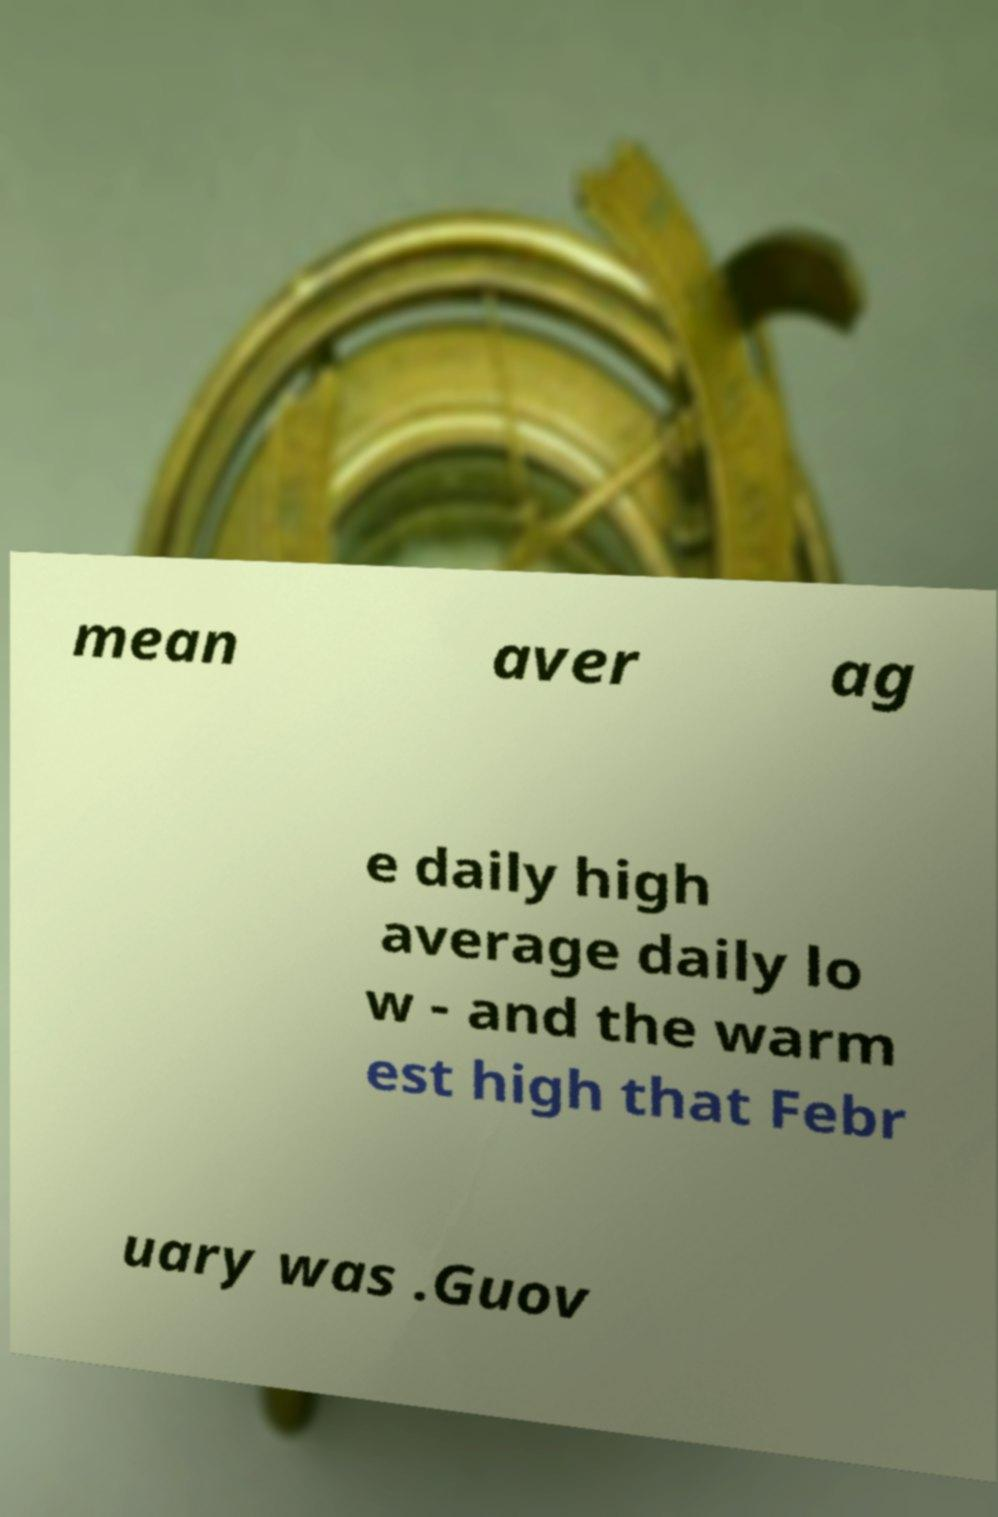Could you assist in decoding the text presented in this image and type it out clearly? mean aver ag e daily high average daily lo w - and the warm est high that Febr uary was .Guov 